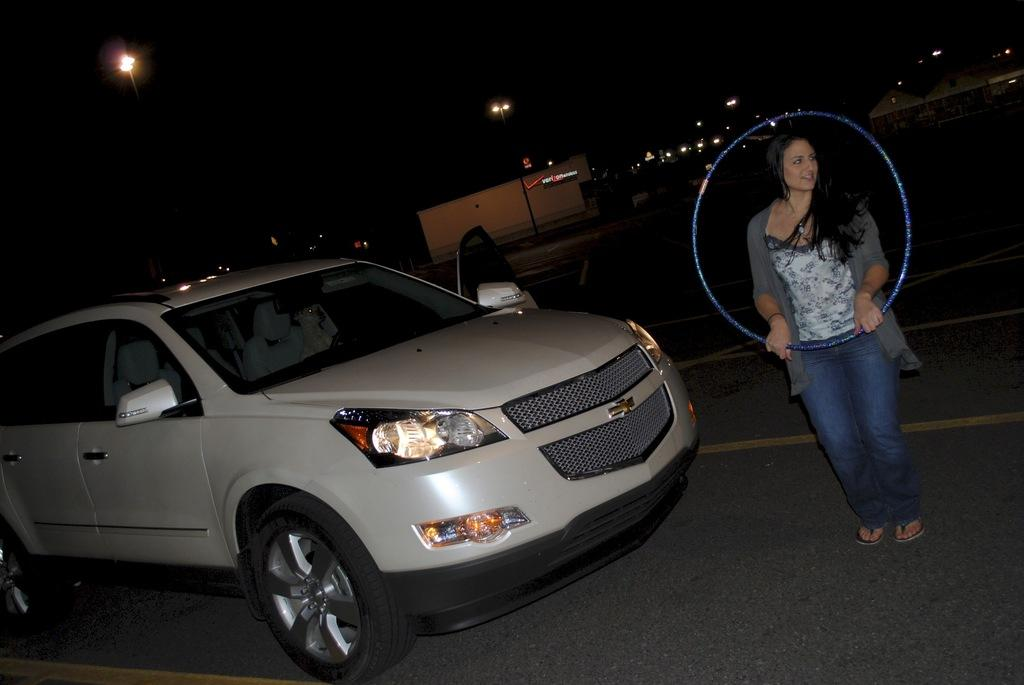What type of vehicle is in the image? There is a white car in the image. Who is present in the image besides the car? A lady is standing in the image. What is the lady holding in the image? The lady is holding a hula hoop. What can be seen in the background of the image? There are buildings and street lights in the background of the image. What is the setting of the image? The image depicts a road. Where is the plant located in the image? There is no plant present in the image. What type of sport is being played with the volleyball in the image? There is no volleyball present in the image. 